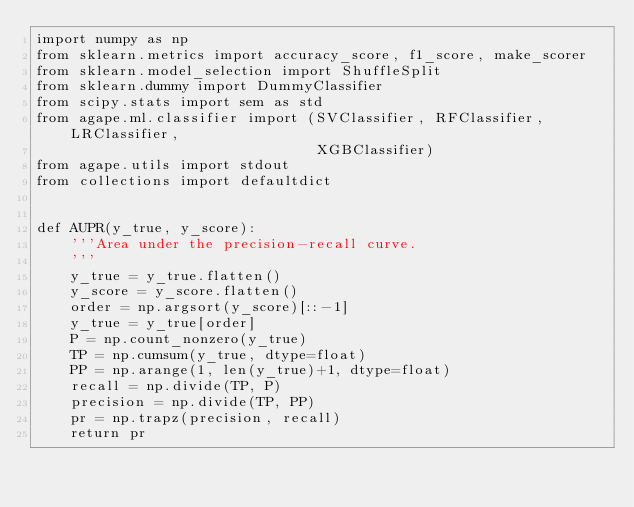<code> <loc_0><loc_0><loc_500><loc_500><_Python_>import numpy as np
from sklearn.metrics import accuracy_score, f1_score, make_scorer
from sklearn.model_selection import ShuffleSplit
from sklearn.dummy import DummyClassifier
from scipy.stats import sem as std
from agape.ml.classifier import (SVClassifier, RFClassifier, LRClassifier,
                                 XGBClassifier)
from agape.utils import stdout
from collections import defaultdict


def AUPR(y_true, y_score):
    '''Area under the precision-recall curve.
    '''
    y_true = y_true.flatten()
    y_score = y_score.flatten()
    order = np.argsort(y_score)[::-1]
    y_true = y_true[order]
    P = np.count_nonzero(y_true)
    TP = np.cumsum(y_true, dtype=float)
    PP = np.arange(1, len(y_true)+1, dtype=float)
    recall = np.divide(TP, P)
    precision = np.divide(TP, PP)
    pr = np.trapz(precision, recall)
    return pr

</code> 